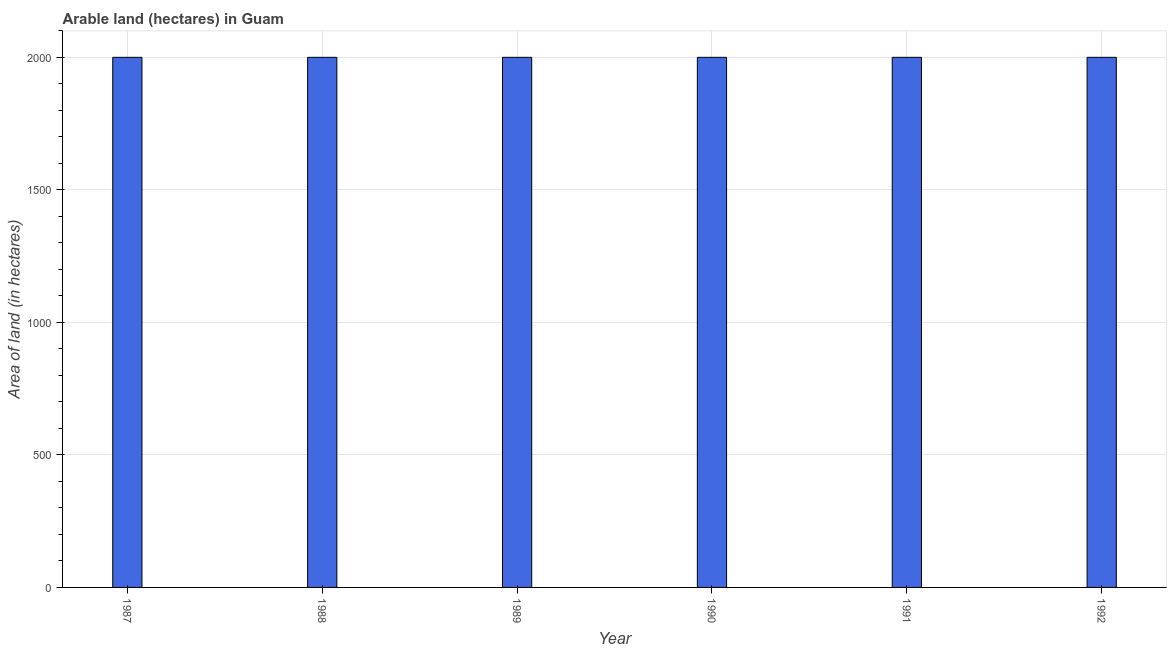Does the graph contain grids?
Provide a succinct answer. Yes. What is the title of the graph?
Give a very brief answer. Arable land (hectares) in Guam. What is the label or title of the Y-axis?
Keep it short and to the point. Area of land (in hectares). In which year was the area of land maximum?
Provide a short and direct response. 1987. In which year was the area of land minimum?
Provide a succinct answer. 1987. What is the sum of the area of land?
Your answer should be very brief. 1.20e+04. What is the average area of land per year?
Provide a succinct answer. 2000. What is the median area of land?
Give a very brief answer. 2000. Is the area of land in 1988 less than that in 1989?
Offer a very short reply. No. Is the sum of the area of land in 1990 and 1992 greater than the maximum area of land across all years?
Ensure brevity in your answer.  Yes. How many bars are there?
Provide a short and direct response. 6. Are all the bars in the graph horizontal?
Keep it short and to the point. No. How many years are there in the graph?
Provide a succinct answer. 6. What is the Area of land (in hectares) of 1987?
Give a very brief answer. 2000. What is the Area of land (in hectares) in 1988?
Provide a succinct answer. 2000. What is the Area of land (in hectares) of 1990?
Your response must be concise. 2000. What is the Area of land (in hectares) of 1991?
Your response must be concise. 2000. What is the Area of land (in hectares) of 1992?
Give a very brief answer. 2000. What is the difference between the Area of land (in hectares) in 1987 and 1988?
Provide a short and direct response. 0. What is the difference between the Area of land (in hectares) in 1987 and 1989?
Ensure brevity in your answer.  0. What is the difference between the Area of land (in hectares) in 1987 and 1990?
Ensure brevity in your answer.  0. What is the difference between the Area of land (in hectares) in 1987 and 1991?
Keep it short and to the point. 0. What is the difference between the Area of land (in hectares) in 1987 and 1992?
Offer a very short reply. 0. What is the difference between the Area of land (in hectares) in 1988 and 1991?
Offer a terse response. 0. What is the difference between the Area of land (in hectares) in 1989 and 1990?
Your answer should be compact. 0. What is the difference between the Area of land (in hectares) in 1989 and 1992?
Ensure brevity in your answer.  0. What is the difference between the Area of land (in hectares) in 1990 and 1992?
Give a very brief answer. 0. What is the ratio of the Area of land (in hectares) in 1987 to that in 1988?
Your response must be concise. 1. What is the ratio of the Area of land (in hectares) in 1987 to that in 1989?
Provide a short and direct response. 1. What is the ratio of the Area of land (in hectares) in 1987 to that in 1990?
Your response must be concise. 1. What is the ratio of the Area of land (in hectares) in 1987 to that in 1992?
Your answer should be compact. 1. What is the ratio of the Area of land (in hectares) in 1988 to that in 1989?
Keep it short and to the point. 1. What is the ratio of the Area of land (in hectares) in 1988 to that in 1990?
Offer a very short reply. 1. What is the ratio of the Area of land (in hectares) in 1989 to that in 1990?
Your answer should be very brief. 1. What is the ratio of the Area of land (in hectares) in 1989 to that in 1992?
Offer a terse response. 1. What is the ratio of the Area of land (in hectares) in 1991 to that in 1992?
Provide a short and direct response. 1. 